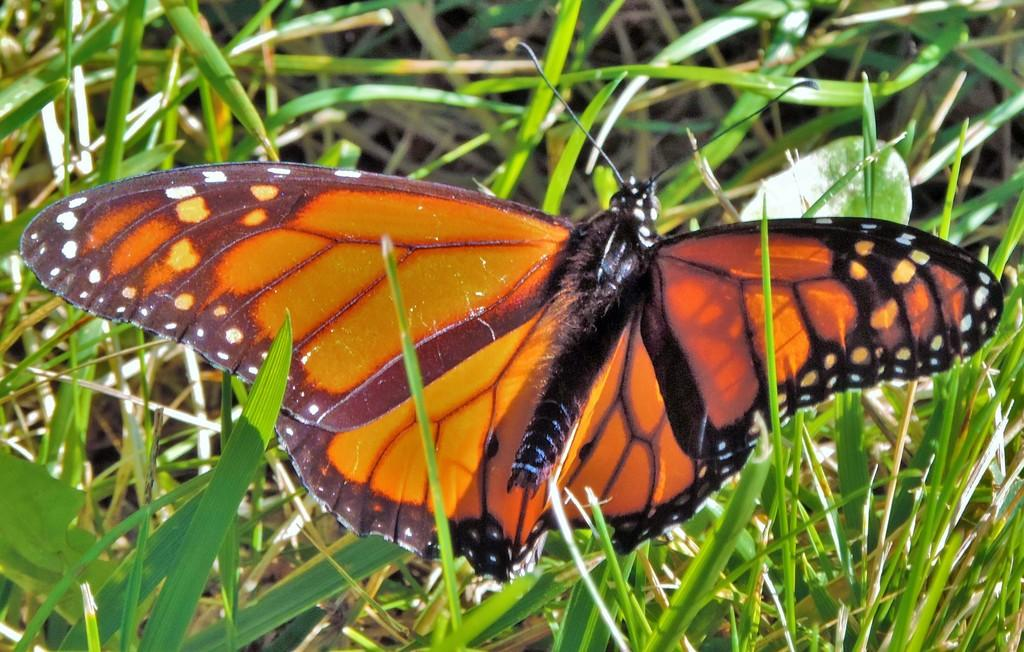What is the main subject of the image? There is a butterfly in the image. Where is the butterfly located in the image? The butterfly is on the plants. What is the name of the downtown street that the butterfly is walking on in the image? There is no downtown street or walking activity depicted in the image; it features a butterfly on plants. What is the elbow's role in the image? There is no elbow present in the image, so it does not have a role. 